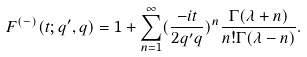<formula> <loc_0><loc_0><loc_500><loc_500>F ^ { ( - ) } ( t ; q ^ { \prime } , q ) = 1 + \sum _ { n = 1 } ^ { \infty } ( \frac { - i t } { 2 q ^ { \prime } q } ) ^ { n } \frac { \Gamma ( \lambda + n ) } { n ! \Gamma ( \lambda - n ) } .</formula> 